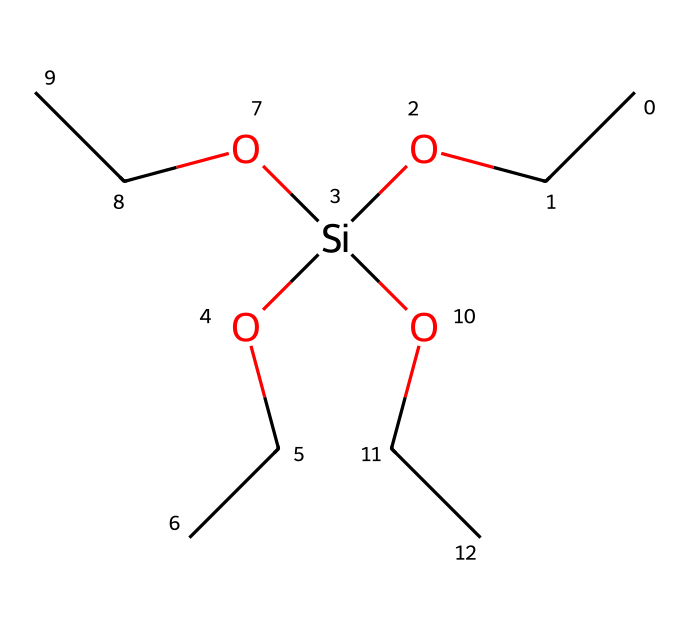What is the main functional group in this silane? The main functional group is the silanol group, indicated by the silicon atom bonded to hydroxyl groups and alkoxy groups. In this case, the silanol groups, represented by "OCC," suggest the presence of multiple alkoxy functionalities.
Answer: silanol How many carbon atoms are present in this structure? By analyzing the structure, there are four "C" atoms present in the three ethoxy groups (OCC) plus one from the main chain, totaling four.
Answer: four What is the connectivity of the silicon atom in this silane? The silicon atom is connected to three ethoxy groups and one hydroxyl (-OH) group, making it a tetrahedral coordination around the silicon atom.
Answer: tetrahedral What type of chemical compound does this silane belong to? This compound is a silane due to the presence of silicon bonded to carbon and oxygen groups, specifically categorized as an organosilicon compound.
Answer: organosilicon How many total oxygen atoms are in this chemical structure? The structure has four oxygen atoms: one from the silanol group and three from the three ethoxy groups (OCC).
Answer: four Which part of this chemical represents its potential for enhancing durability in pottery? The presence of alkoxy groups (OCC) indicates that this silane can enhance bonding to substrates, providing improved durability and water repellence when applied to pottery.
Answer: alkoxy groups 